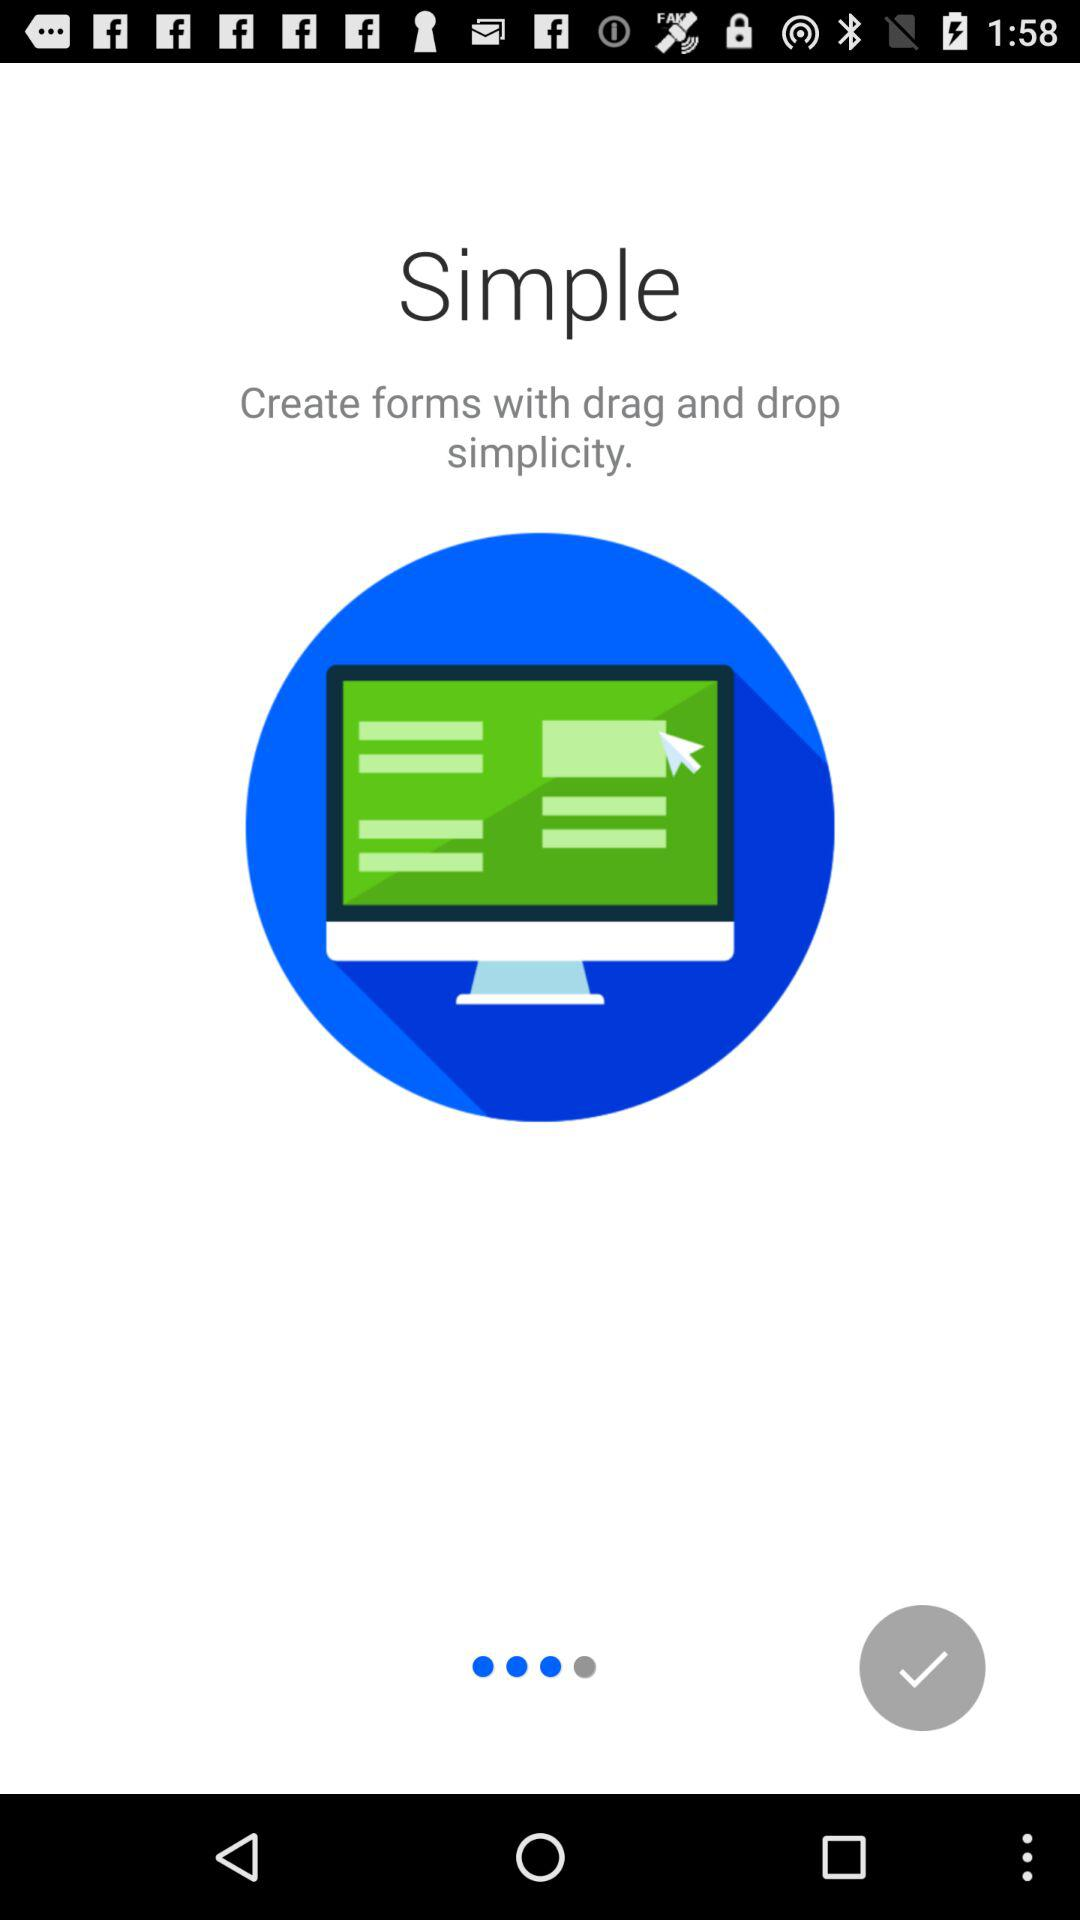What is the app name? The app name is "Simple". 